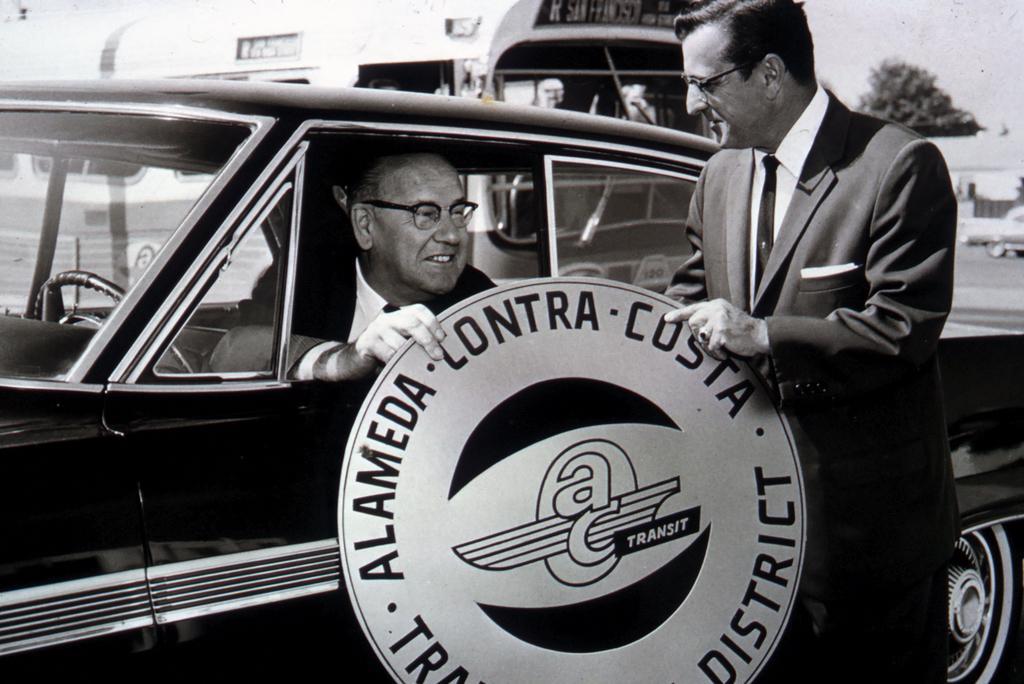Can you describe this image briefly? On the left a man is sitting in a car on the right a man is standing behind him there is a tree. 